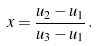<formula> <loc_0><loc_0><loc_500><loc_500>x = \frac { u _ { 2 } - u _ { 1 } } { u _ { 3 } - u _ { 1 } } \, .</formula> 